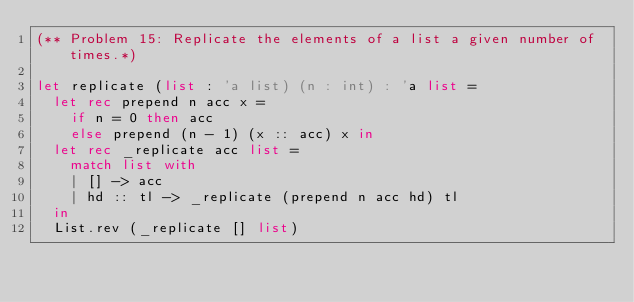Convert code to text. <code><loc_0><loc_0><loc_500><loc_500><_OCaml_>(** Problem 15: Replicate the elements of a list a given number of times.*)

let replicate (list : 'a list) (n : int) : 'a list =
  let rec prepend n acc x =
    if n = 0 then acc
    else prepend (n - 1) (x :: acc) x in
  let rec _replicate acc list =
    match list with
    | [] -> acc
    | hd :: tl -> _replicate (prepend n acc hd) tl
  in
  List.rev (_replicate [] list)

</code> 